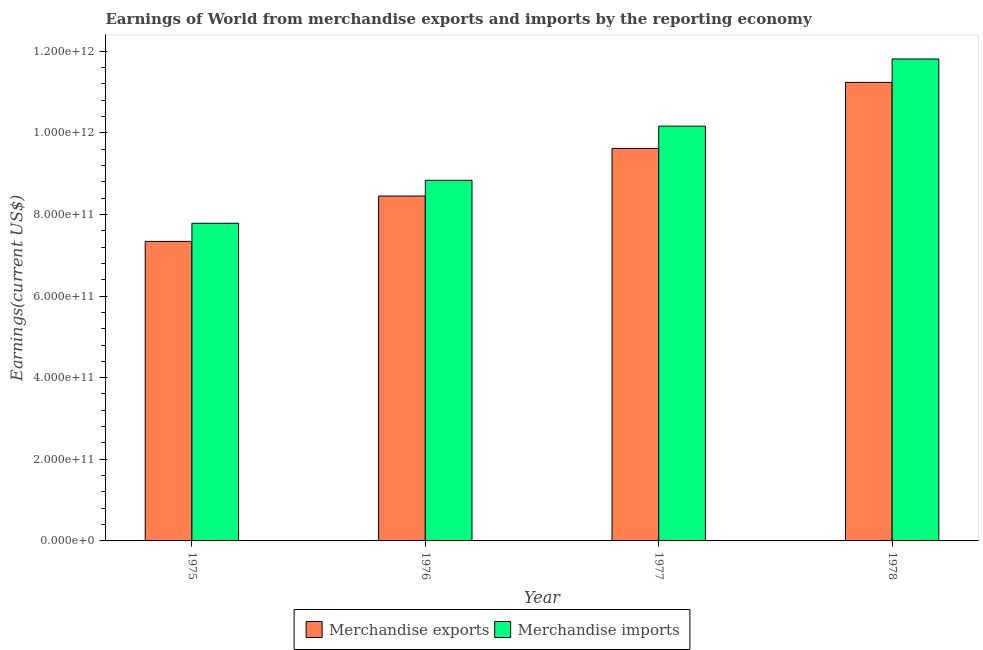How many groups of bars are there?
Ensure brevity in your answer.  4. What is the label of the 2nd group of bars from the left?
Your answer should be compact. 1976. In how many cases, is the number of bars for a given year not equal to the number of legend labels?
Offer a terse response. 0. What is the earnings from merchandise exports in 1977?
Give a very brief answer. 9.62e+11. Across all years, what is the maximum earnings from merchandise exports?
Provide a short and direct response. 1.12e+12. Across all years, what is the minimum earnings from merchandise imports?
Provide a succinct answer. 7.78e+11. In which year was the earnings from merchandise imports maximum?
Offer a very short reply. 1978. In which year was the earnings from merchandise exports minimum?
Keep it short and to the point. 1975. What is the total earnings from merchandise imports in the graph?
Offer a terse response. 3.86e+12. What is the difference between the earnings from merchandise imports in 1977 and that in 1978?
Provide a succinct answer. -1.65e+11. What is the difference between the earnings from merchandise exports in 1977 and the earnings from merchandise imports in 1975?
Give a very brief answer. 2.28e+11. What is the average earnings from merchandise exports per year?
Offer a very short reply. 9.16e+11. In the year 1976, what is the difference between the earnings from merchandise imports and earnings from merchandise exports?
Your response must be concise. 0. What is the ratio of the earnings from merchandise exports in 1977 to that in 1978?
Offer a terse response. 0.86. Is the difference between the earnings from merchandise imports in 1975 and 1978 greater than the difference between the earnings from merchandise exports in 1975 and 1978?
Give a very brief answer. No. What is the difference between the highest and the second highest earnings from merchandise imports?
Your answer should be compact. 1.65e+11. What is the difference between the highest and the lowest earnings from merchandise exports?
Keep it short and to the point. 3.90e+11. In how many years, is the earnings from merchandise exports greater than the average earnings from merchandise exports taken over all years?
Your answer should be compact. 2. Is the sum of the earnings from merchandise imports in 1977 and 1978 greater than the maximum earnings from merchandise exports across all years?
Your answer should be compact. Yes. What does the 1st bar from the left in 1977 represents?
Provide a succinct answer. Merchandise exports. Are all the bars in the graph horizontal?
Offer a very short reply. No. How many years are there in the graph?
Ensure brevity in your answer.  4. What is the difference between two consecutive major ticks on the Y-axis?
Offer a very short reply. 2.00e+11. Are the values on the major ticks of Y-axis written in scientific E-notation?
Give a very brief answer. Yes. Does the graph contain grids?
Your response must be concise. No. Where does the legend appear in the graph?
Make the answer very short. Bottom center. How many legend labels are there?
Offer a terse response. 2. How are the legend labels stacked?
Ensure brevity in your answer.  Horizontal. What is the title of the graph?
Give a very brief answer. Earnings of World from merchandise exports and imports by the reporting economy. What is the label or title of the Y-axis?
Your response must be concise. Earnings(current US$). What is the Earnings(current US$) in Merchandise exports in 1975?
Your answer should be compact. 7.34e+11. What is the Earnings(current US$) of Merchandise imports in 1975?
Your response must be concise. 7.78e+11. What is the Earnings(current US$) of Merchandise exports in 1976?
Make the answer very short. 8.45e+11. What is the Earnings(current US$) in Merchandise imports in 1976?
Offer a very short reply. 8.84e+11. What is the Earnings(current US$) of Merchandise exports in 1977?
Your answer should be compact. 9.62e+11. What is the Earnings(current US$) in Merchandise imports in 1977?
Keep it short and to the point. 1.02e+12. What is the Earnings(current US$) of Merchandise exports in 1978?
Your answer should be compact. 1.12e+12. What is the Earnings(current US$) of Merchandise imports in 1978?
Provide a short and direct response. 1.18e+12. Across all years, what is the maximum Earnings(current US$) in Merchandise exports?
Offer a terse response. 1.12e+12. Across all years, what is the maximum Earnings(current US$) of Merchandise imports?
Offer a terse response. 1.18e+12. Across all years, what is the minimum Earnings(current US$) of Merchandise exports?
Offer a terse response. 7.34e+11. Across all years, what is the minimum Earnings(current US$) in Merchandise imports?
Your response must be concise. 7.78e+11. What is the total Earnings(current US$) of Merchandise exports in the graph?
Offer a very short reply. 3.66e+12. What is the total Earnings(current US$) in Merchandise imports in the graph?
Offer a terse response. 3.86e+12. What is the difference between the Earnings(current US$) of Merchandise exports in 1975 and that in 1976?
Provide a succinct answer. -1.11e+11. What is the difference between the Earnings(current US$) in Merchandise imports in 1975 and that in 1976?
Your answer should be compact. -1.05e+11. What is the difference between the Earnings(current US$) of Merchandise exports in 1975 and that in 1977?
Provide a short and direct response. -2.28e+11. What is the difference between the Earnings(current US$) of Merchandise imports in 1975 and that in 1977?
Offer a terse response. -2.38e+11. What is the difference between the Earnings(current US$) of Merchandise exports in 1975 and that in 1978?
Make the answer very short. -3.90e+11. What is the difference between the Earnings(current US$) in Merchandise imports in 1975 and that in 1978?
Ensure brevity in your answer.  -4.03e+11. What is the difference between the Earnings(current US$) of Merchandise exports in 1976 and that in 1977?
Keep it short and to the point. -1.17e+11. What is the difference between the Earnings(current US$) of Merchandise imports in 1976 and that in 1977?
Keep it short and to the point. -1.33e+11. What is the difference between the Earnings(current US$) in Merchandise exports in 1976 and that in 1978?
Provide a short and direct response. -2.78e+11. What is the difference between the Earnings(current US$) in Merchandise imports in 1976 and that in 1978?
Ensure brevity in your answer.  -2.97e+11. What is the difference between the Earnings(current US$) in Merchandise exports in 1977 and that in 1978?
Make the answer very short. -1.62e+11. What is the difference between the Earnings(current US$) in Merchandise imports in 1977 and that in 1978?
Offer a very short reply. -1.65e+11. What is the difference between the Earnings(current US$) in Merchandise exports in 1975 and the Earnings(current US$) in Merchandise imports in 1976?
Ensure brevity in your answer.  -1.50e+11. What is the difference between the Earnings(current US$) of Merchandise exports in 1975 and the Earnings(current US$) of Merchandise imports in 1977?
Give a very brief answer. -2.82e+11. What is the difference between the Earnings(current US$) of Merchandise exports in 1975 and the Earnings(current US$) of Merchandise imports in 1978?
Your response must be concise. -4.47e+11. What is the difference between the Earnings(current US$) in Merchandise exports in 1976 and the Earnings(current US$) in Merchandise imports in 1977?
Offer a terse response. -1.71e+11. What is the difference between the Earnings(current US$) in Merchandise exports in 1976 and the Earnings(current US$) in Merchandise imports in 1978?
Your answer should be compact. -3.36e+11. What is the difference between the Earnings(current US$) in Merchandise exports in 1977 and the Earnings(current US$) in Merchandise imports in 1978?
Give a very brief answer. -2.19e+11. What is the average Earnings(current US$) of Merchandise exports per year?
Keep it short and to the point. 9.16e+11. What is the average Earnings(current US$) of Merchandise imports per year?
Your answer should be compact. 9.65e+11. In the year 1975, what is the difference between the Earnings(current US$) of Merchandise exports and Earnings(current US$) of Merchandise imports?
Keep it short and to the point. -4.44e+1. In the year 1976, what is the difference between the Earnings(current US$) of Merchandise exports and Earnings(current US$) of Merchandise imports?
Your answer should be compact. -3.86e+1. In the year 1977, what is the difference between the Earnings(current US$) of Merchandise exports and Earnings(current US$) of Merchandise imports?
Your response must be concise. -5.46e+1. In the year 1978, what is the difference between the Earnings(current US$) in Merchandise exports and Earnings(current US$) in Merchandise imports?
Give a very brief answer. -5.74e+1. What is the ratio of the Earnings(current US$) of Merchandise exports in 1975 to that in 1976?
Ensure brevity in your answer.  0.87. What is the ratio of the Earnings(current US$) in Merchandise imports in 1975 to that in 1976?
Offer a terse response. 0.88. What is the ratio of the Earnings(current US$) in Merchandise exports in 1975 to that in 1977?
Provide a succinct answer. 0.76. What is the ratio of the Earnings(current US$) in Merchandise imports in 1975 to that in 1977?
Keep it short and to the point. 0.77. What is the ratio of the Earnings(current US$) in Merchandise exports in 1975 to that in 1978?
Your answer should be compact. 0.65. What is the ratio of the Earnings(current US$) of Merchandise imports in 1975 to that in 1978?
Your answer should be very brief. 0.66. What is the ratio of the Earnings(current US$) of Merchandise exports in 1976 to that in 1977?
Offer a very short reply. 0.88. What is the ratio of the Earnings(current US$) of Merchandise imports in 1976 to that in 1977?
Your response must be concise. 0.87. What is the ratio of the Earnings(current US$) in Merchandise exports in 1976 to that in 1978?
Ensure brevity in your answer.  0.75. What is the ratio of the Earnings(current US$) of Merchandise imports in 1976 to that in 1978?
Offer a very short reply. 0.75. What is the ratio of the Earnings(current US$) in Merchandise exports in 1977 to that in 1978?
Your answer should be compact. 0.86. What is the ratio of the Earnings(current US$) in Merchandise imports in 1977 to that in 1978?
Your answer should be very brief. 0.86. What is the difference between the highest and the second highest Earnings(current US$) in Merchandise exports?
Ensure brevity in your answer.  1.62e+11. What is the difference between the highest and the second highest Earnings(current US$) of Merchandise imports?
Provide a short and direct response. 1.65e+11. What is the difference between the highest and the lowest Earnings(current US$) in Merchandise exports?
Give a very brief answer. 3.90e+11. What is the difference between the highest and the lowest Earnings(current US$) in Merchandise imports?
Your answer should be compact. 4.03e+11. 